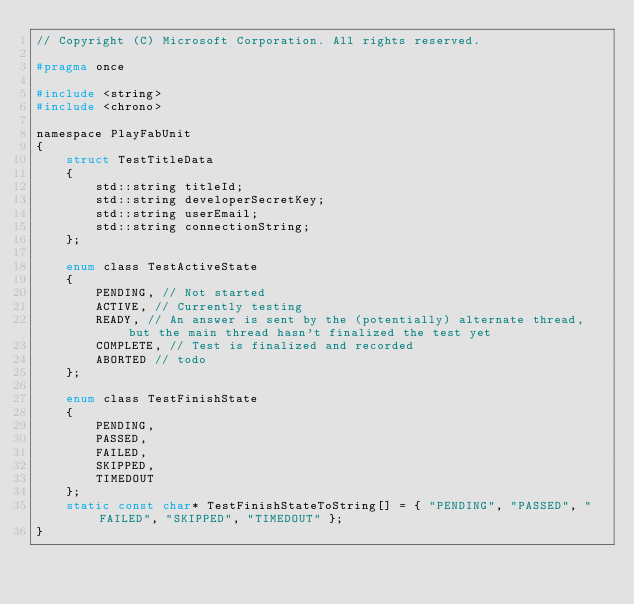Convert code to text. <code><loc_0><loc_0><loc_500><loc_500><_C_>// Copyright (C) Microsoft Corporation. All rights reserved.

#pragma once

#include <string>
#include <chrono>

namespace PlayFabUnit
{
    struct TestTitleData
    {
        std::string titleId;
        std::string developerSecretKey;
        std::string userEmail;
        std::string connectionString;
    };

    enum class TestActiveState
    {
        PENDING, // Not started
        ACTIVE, // Currently testing
        READY, // An answer is sent by the (potentially) alternate thread, but the main thread hasn't finalized the test yet
        COMPLETE, // Test is finalized and recorded
        ABORTED // todo
    };

    enum class TestFinishState
    {
        PENDING,
        PASSED,
        FAILED,
        SKIPPED,
        TIMEDOUT
    };
    static const char* TestFinishStateToString[] = { "PENDING", "PASSED", "FAILED", "SKIPPED", "TIMEDOUT" };
}
</code> 